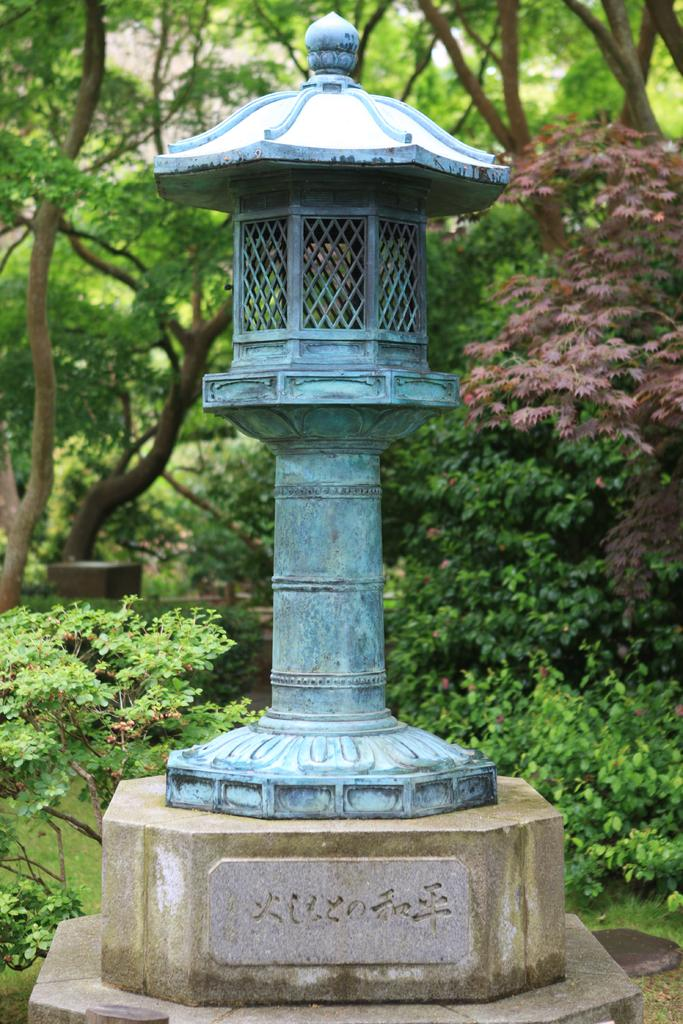What is on the wall in the image? There is an object on the wall in the image. What else can be seen on the wall in the image? There is text on the wall in the image. What type of natural environment is visible in the background of the image? Trees are visible in the background of the image. Can you describe the ground in the image? Grass is present at the bottom of the image. What is the daughter's name in the image? There is no daughter present in the image. What is the tendency of the object on the wall in the image? The provided facts do not mention any tendency of the object on the wall; it only states that there is an object on the wall. 